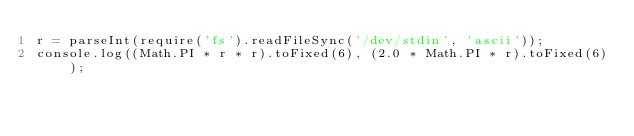Convert code to text. <code><loc_0><loc_0><loc_500><loc_500><_JavaScript_>r = parseInt(require('fs').readFileSync('/dev/stdin', 'ascii'));
console.log((Math.PI * r * r).toFixed(6), (2.0 * Math.PI * r).toFixed(6));</code> 